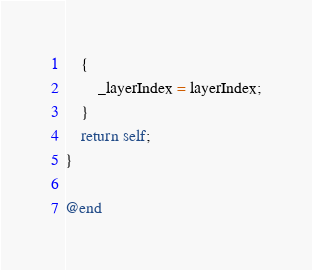Convert code to text. <code><loc_0><loc_0><loc_500><loc_500><_ObjectiveC_>    {
        _layerIndex = layerIndex;
    }
    return self;
}

@end
</code> 